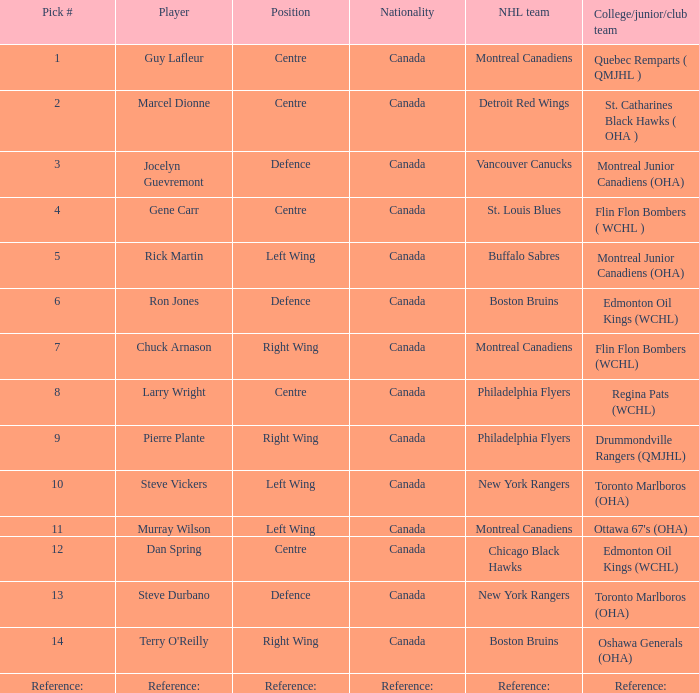Which College/junior/club team has a Pick # of 1? Quebec Remparts ( QMJHL ). 